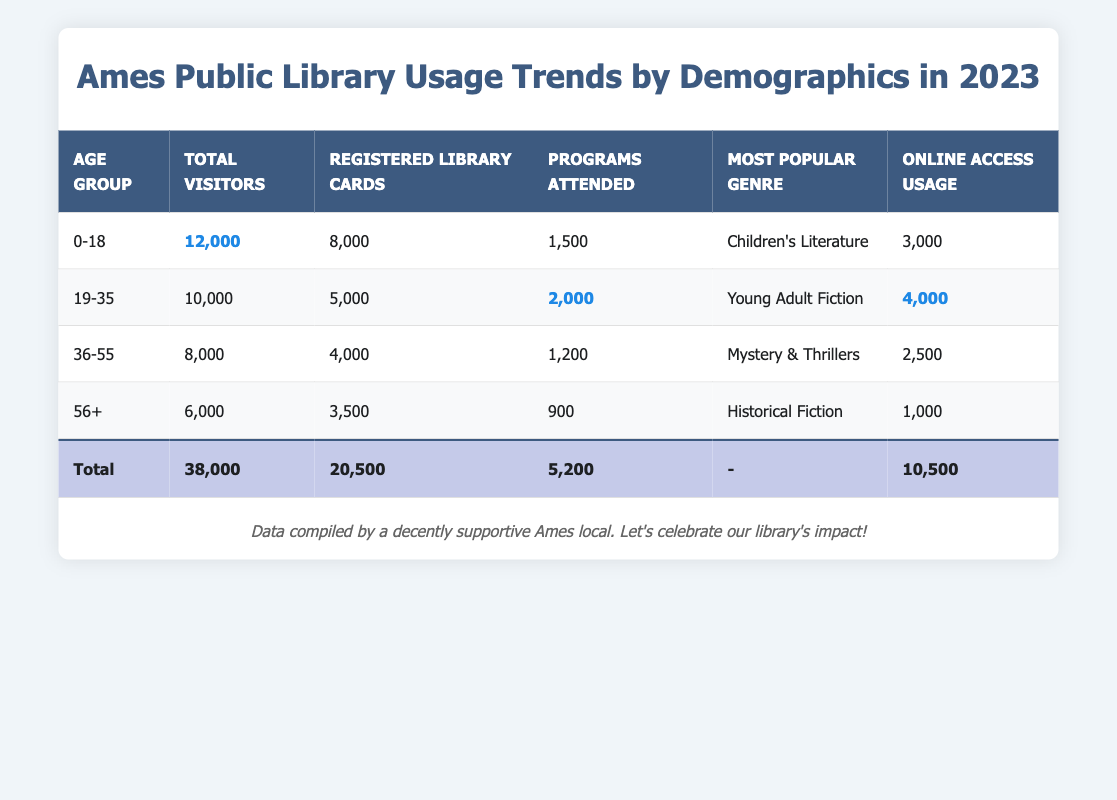What is the total number of visitors to the Ames Public Library in 2023? The total number of visitors is recorded in the “Total” row of the table, which indicates that there are 38,000 overall visitors.
Answer: 38,000 Which age group has the highest number of registered library cards? By comparing the "Registered Library Cards" column for each age group, the “0-18” group has the highest at 8,000.
Answer: 0-18 How many programs were attended by visitors aged 19-35? The number of programs attended by the 19-35 age group is directly shown in the table as 2,000.
Answer: 2,000 What is the most popular genre for visitors aged 36-55? The table specifies that the most popular genre for the 36-55 age group is “Mystery & Thrillers.”
Answer: Mystery & Thrillers What is the total number of online access usage for all age groups combined? Adding the “Online Access Usage” for each age group gives (3,000 + 4,000 + 2,500 + 1,000 = 10,500), which matches the total in the summary row of the table.
Answer: 10,500 Which age group has the least number of programs attended? By reviewing the "Programs Attended" column, the “56+” age group has the least number at 900.
Answer: 56+ What percentage of total visitors are aged 0-18? To find the percentage, divide the visitors aged 0-18 (12,000) by the total visitors (38,000) and multiply by 100: (12,000 / 38,000) * 100 = 31.57%.
Answer: 31.57% If the online access usage continues to grow at the same rate, how many users can we expect next year from the 19-35 age group? The 19-35 age group has an online access usage of 4,000. If the pattern holds, we can expect this number to remain about the same next year.
Answer: 4,000 Is it true that the total number of registered library cards exceeds the total number of programs attended? Checking the totals, there are 20,500 registered library cards and 5,200 programs attended, confirming that the statement is true.
Answer: True What is the average number of visitors across all age groups? To find the average, sum the number of visitors (12,000 + 10,000 + 8,000 + 6,000 = 36,000) and divide by the number of groups (4): 36,000 / 4 = 9,000.
Answer: 9,000 If the 56+ age group increased its visitors by 10% next year, how many visitors would that be? A 10% increase on 6,000 visitors means an additional 600 (6,000 * 0.10 = 600), totaling 6,600 visitors for next year.
Answer: 6,600 